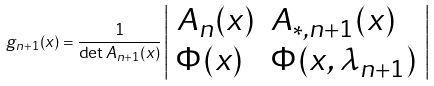<formula> <loc_0><loc_0><loc_500><loc_500>g _ { n + 1 } ( x ) = \frac { 1 } { \det A _ { n + 1 } ( x ) } \left | \begin{array} { l l } A _ { n } ( x ) & A _ { * , n + 1 } ( x ) \\ \Phi ( x ) & \Phi ( x , \lambda _ { n + 1 } ) \end{array} \right |</formula> 